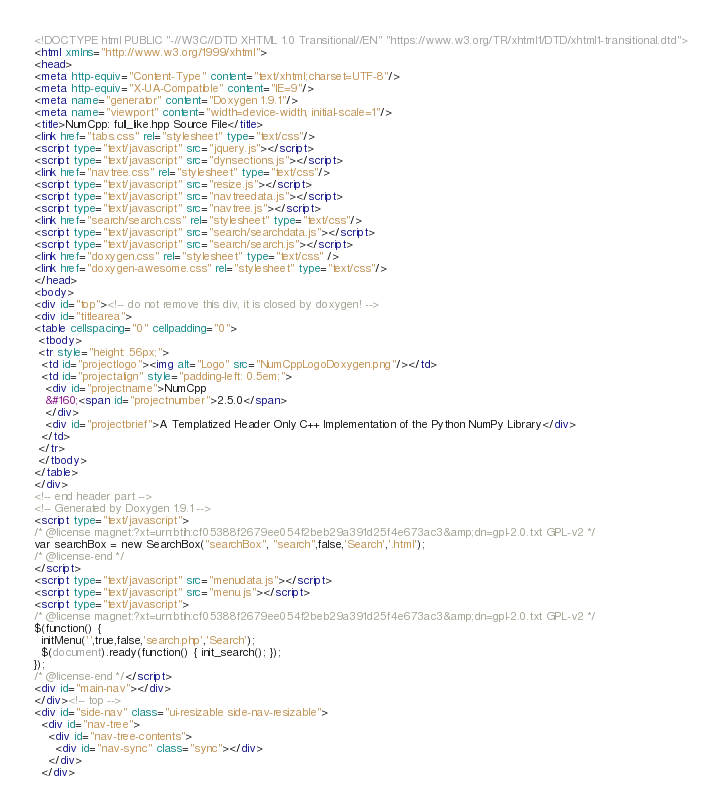<code> <loc_0><loc_0><loc_500><loc_500><_HTML_><!DOCTYPE html PUBLIC "-//W3C//DTD XHTML 1.0 Transitional//EN" "https://www.w3.org/TR/xhtml1/DTD/xhtml1-transitional.dtd">
<html xmlns="http://www.w3.org/1999/xhtml">
<head>
<meta http-equiv="Content-Type" content="text/xhtml;charset=UTF-8"/>
<meta http-equiv="X-UA-Compatible" content="IE=9"/>
<meta name="generator" content="Doxygen 1.9.1"/>
<meta name="viewport" content="width=device-width, initial-scale=1"/>
<title>NumCpp: full_like.hpp Source File</title>
<link href="tabs.css" rel="stylesheet" type="text/css"/>
<script type="text/javascript" src="jquery.js"></script>
<script type="text/javascript" src="dynsections.js"></script>
<link href="navtree.css" rel="stylesheet" type="text/css"/>
<script type="text/javascript" src="resize.js"></script>
<script type="text/javascript" src="navtreedata.js"></script>
<script type="text/javascript" src="navtree.js"></script>
<link href="search/search.css" rel="stylesheet" type="text/css"/>
<script type="text/javascript" src="search/searchdata.js"></script>
<script type="text/javascript" src="search/search.js"></script>
<link href="doxygen.css" rel="stylesheet" type="text/css" />
<link href="doxygen-awesome.css" rel="stylesheet" type="text/css"/>
</head>
<body>
<div id="top"><!-- do not remove this div, it is closed by doxygen! -->
<div id="titlearea">
<table cellspacing="0" cellpadding="0">
 <tbody>
 <tr style="height: 56px;">
  <td id="projectlogo"><img alt="Logo" src="NumCppLogoDoxygen.png"/></td>
  <td id="projectalign" style="padding-left: 0.5em;">
   <div id="projectname">NumCpp
   &#160;<span id="projectnumber">2.5.0</span>
   </div>
   <div id="projectbrief">A Templatized Header Only C++ Implementation of the Python NumPy Library</div>
  </td>
 </tr>
 </tbody>
</table>
</div>
<!-- end header part -->
<!-- Generated by Doxygen 1.9.1 -->
<script type="text/javascript">
/* @license magnet:?xt=urn:btih:cf05388f2679ee054f2beb29a391d25f4e673ac3&amp;dn=gpl-2.0.txt GPL-v2 */
var searchBox = new SearchBox("searchBox", "search",false,'Search','.html');
/* @license-end */
</script>
<script type="text/javascript" src="menudata.js"></script>
<script type="text/javascript" src="menu.js"></script>
<script type="text/javascript">
/* @license magnet:?xt=urn:btih:cf05388f2679ee054f2beb29a391d25f4e673ac3&amp;dn=gpl-2.0.txt GPL-v2 */
$(function() {
  initMenu('',true,false,'search.php','Search');
  $(document).ready(function() { init_search(); });
});
/* @license-end */</script>
<div id="main-nav"></div>
</div><!-- top -->
<div id="side-nav" class="ui-resizable side-nav-resizable">
  <div id="nav-tree">
    <div id="nav-tree-contents">
      <div id="nav-sync" class="sync"></div>
    </div>
  </div></code> 